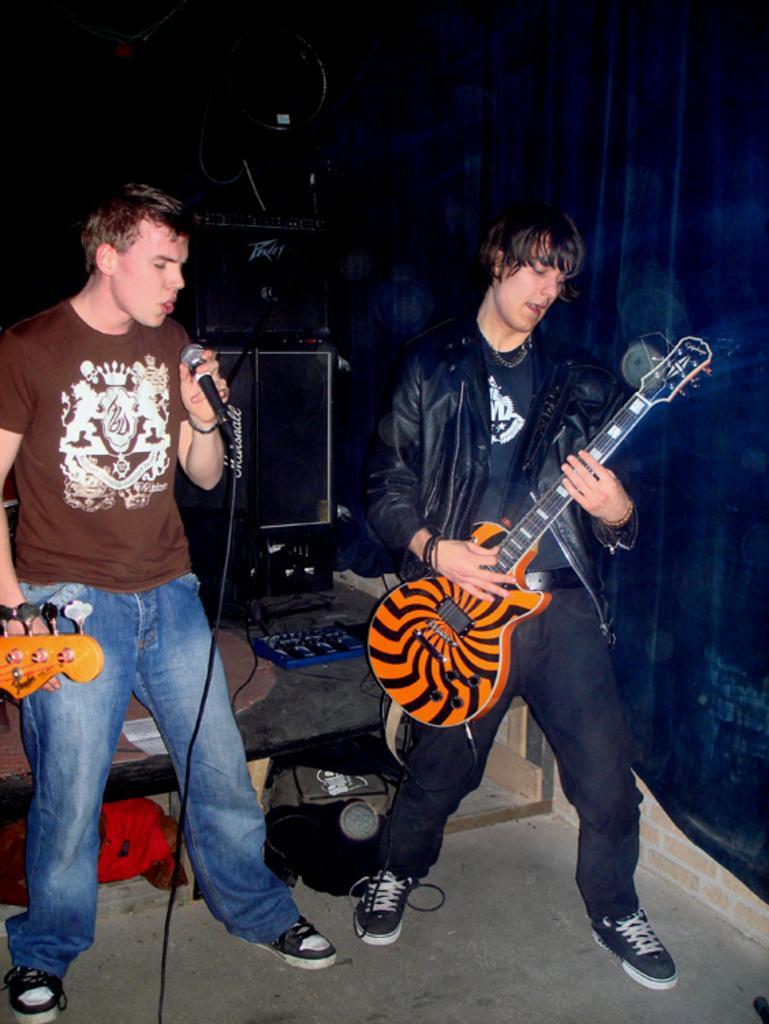Could you give a brief overview of what you see in this image? In this image I see a man who is holding a mic and I see another man who is holding the guitar. In the background I can see an equipment. 